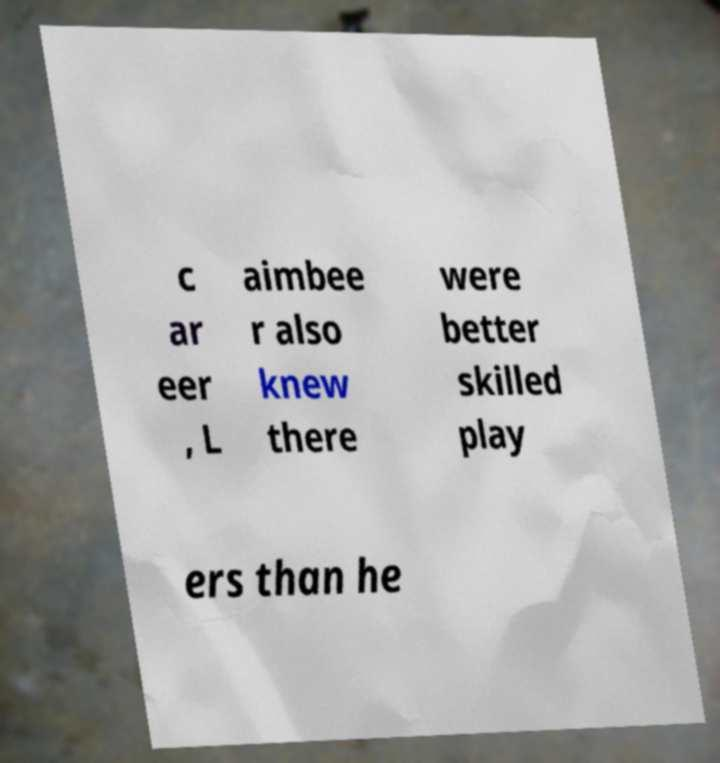There's text embedded in this image that I need extracted. Can you transcribe it verbatim? c ar eer , L aimbee r also knew there were better skilled play ers than he 